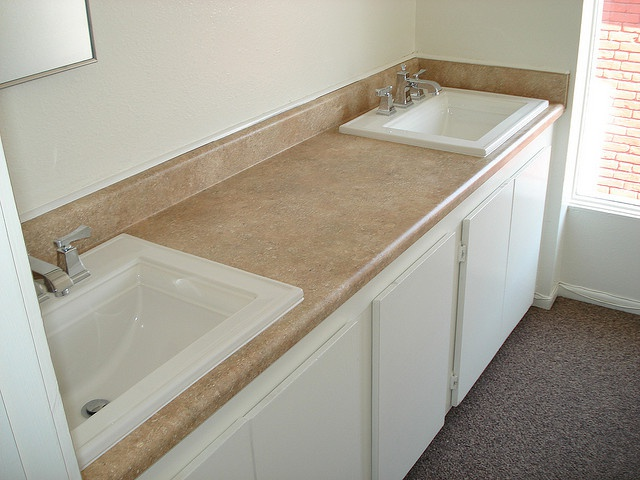Describe the objects in this image and their specific colors. I can see sink in darkgray and gray tones and sink in darkgray, lightgray, and gray tones in this image. 